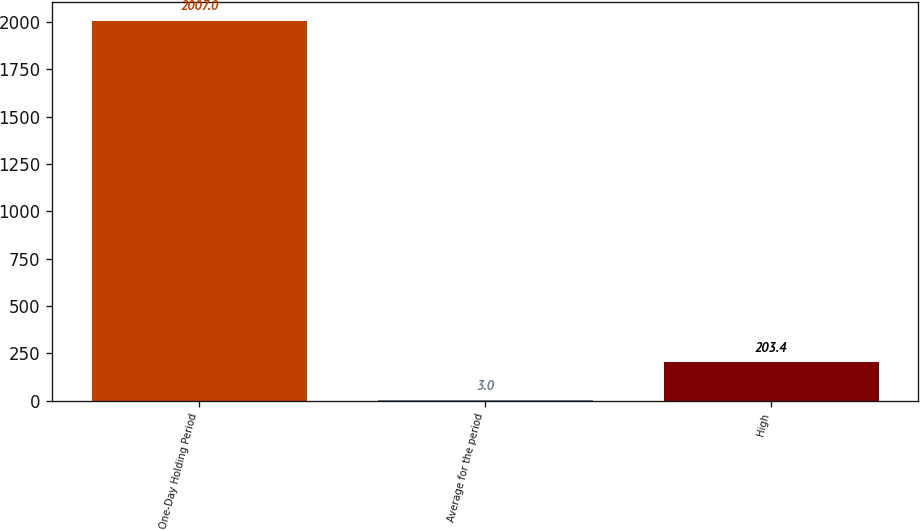Convert chart to OTSL. <chart><loc_0><loc_0><loc_500><loc_500><bar_chart><fcel>One-Day Holding Period<fcel>Average for the period<fcel>High<nl><fcel>2007<fcel>3<fcel>203.4<nl></chart> 